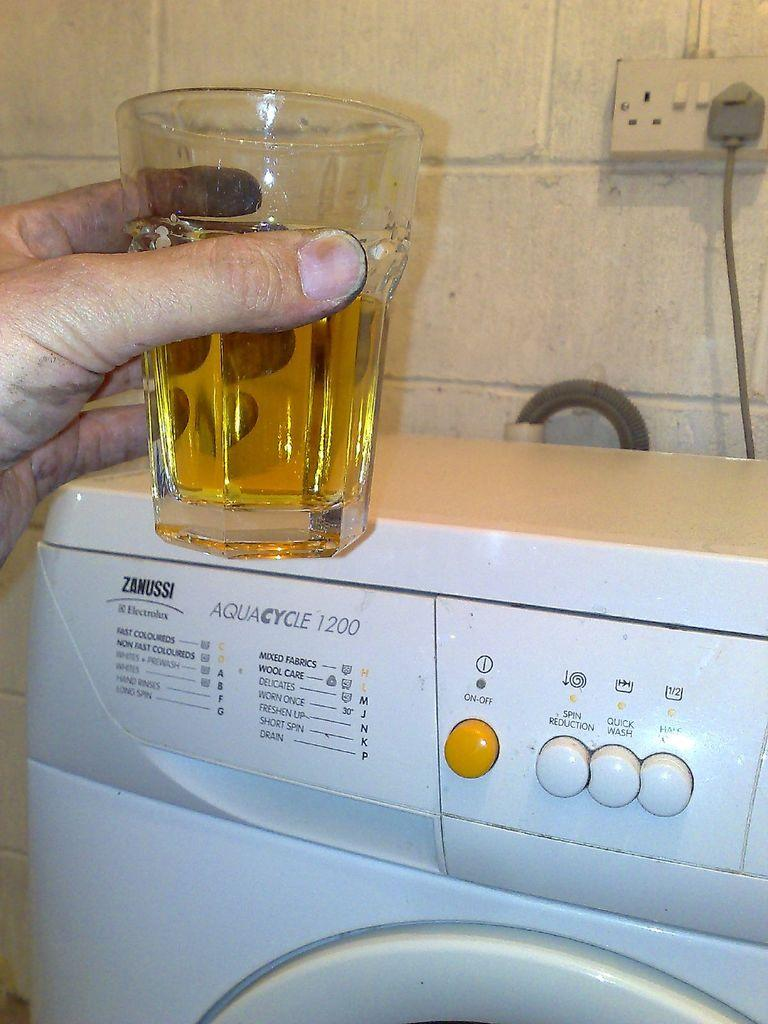<image>
Create a compact narrative representing the image presented. A person holds a glass with liquid in it above a Zanussi washing machine. 